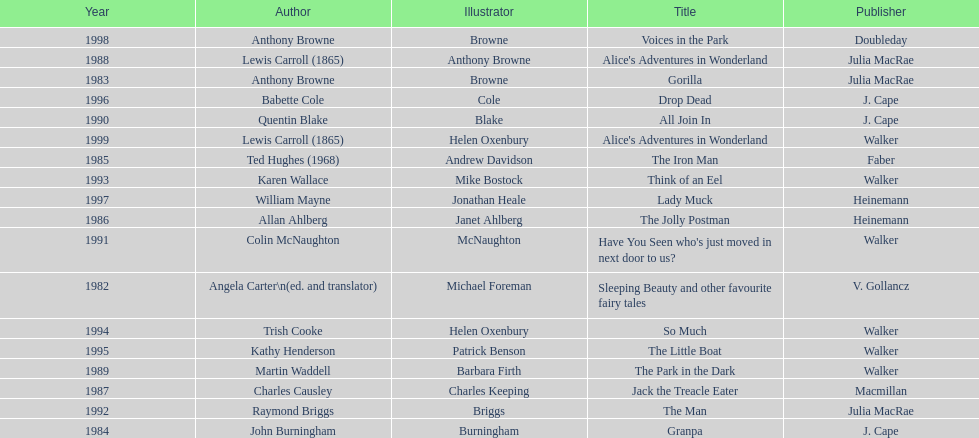How many total titles were published by walker? 5. 